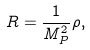<formula> <loc_0><loc_0><loc_500><loc_500>R = \frac { 1 } { M _ { P } ^ { 2 } } \rho ,</formula> 